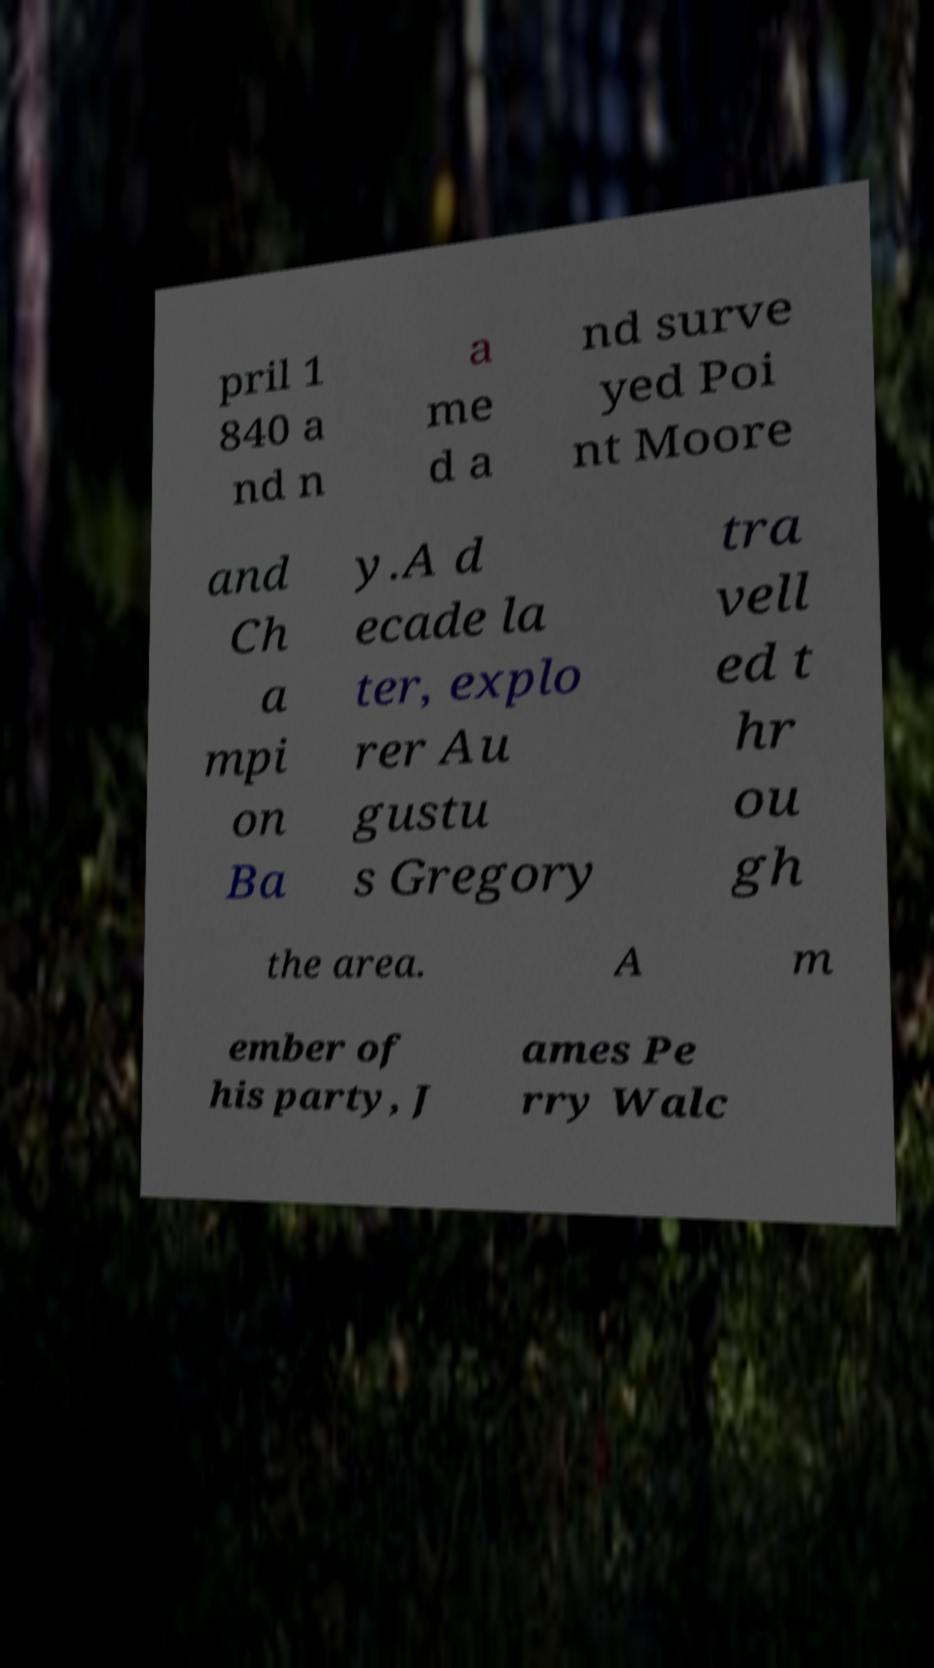For documentation purposes, I need the text within this image transcribed. Could you provide that? pril 1 840 a nd n a me d a nd surve yed Poi nt Moore and Ch a mpi on Ba y.A d ecade la ter, explo rer Au gustu s Gregory tra vell ed t hr ou gh the area. A m ember of his party, J ames Pe rry Walc 